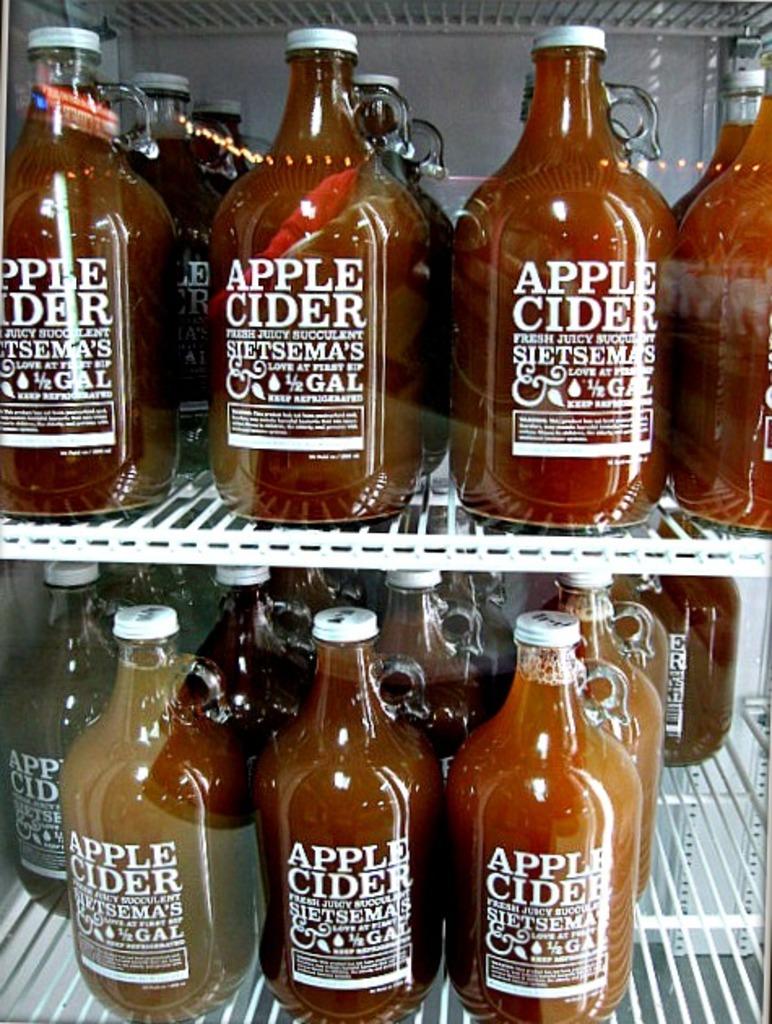What kind of drink is in the bottles?
Provide a succinct answer. Apple cider. How much is in each bottle?
Offer a very short reply. 1/2 gal. 